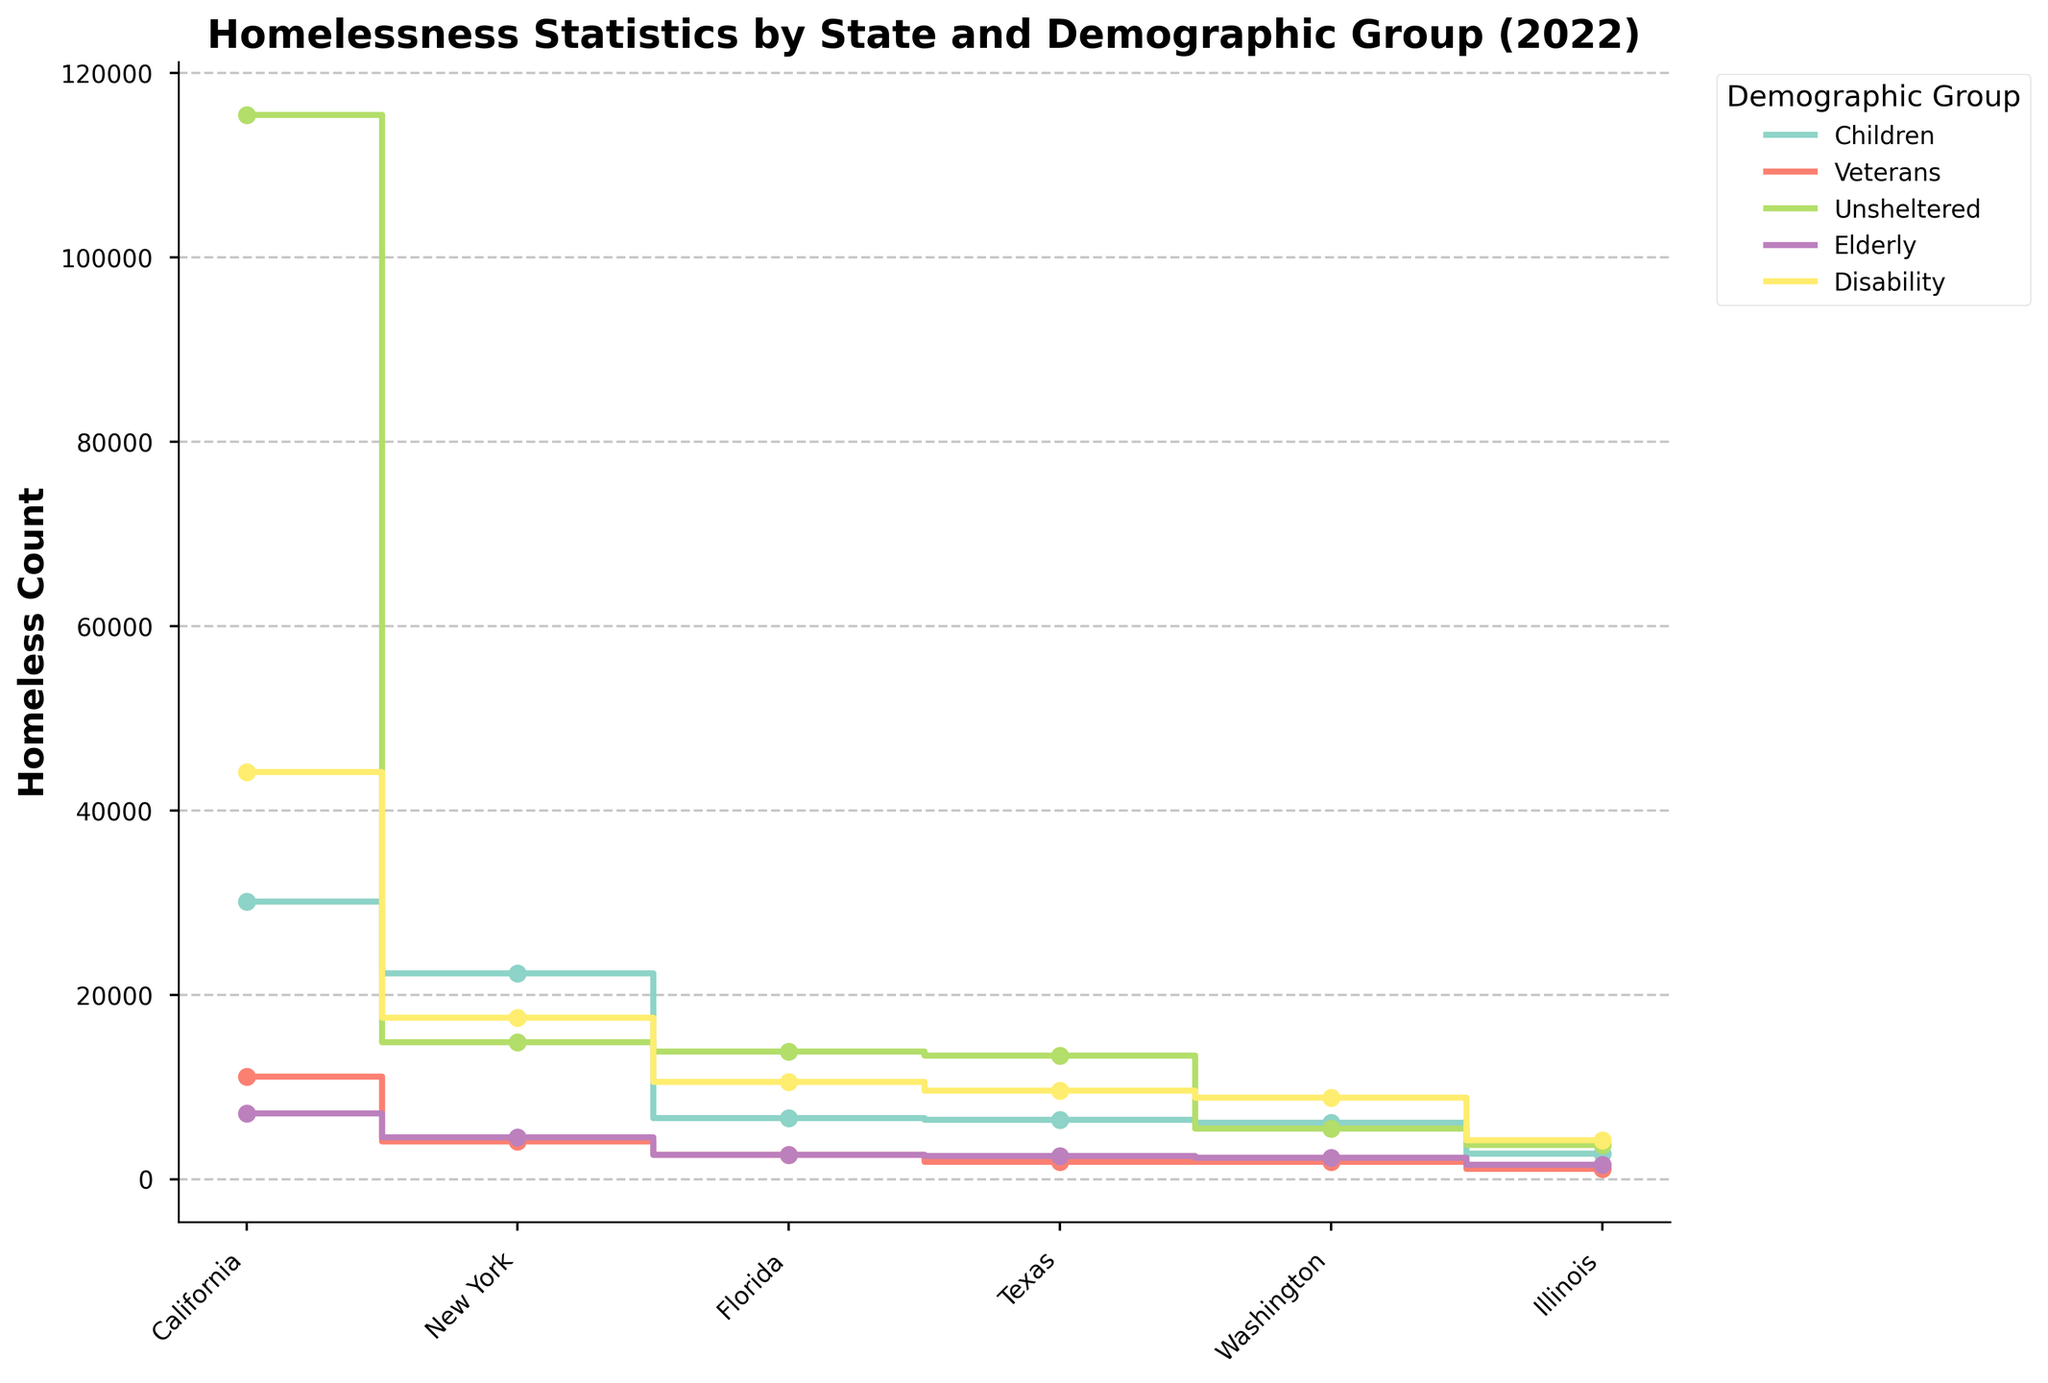Which state has the highest count of unsheltered homeless individuals? In the figure, observe the "Unsheltered" group's stair plot. The highest point corresponds to California.
Answer: California Which demographic group has the second-highest homeless count in New York? In the figure, look at the second highest step for New York's demographic groups. This corresponds to the "Children" demographic.
Answer: Children How does the count of veterans' homelessness in Illinois compare with Texas? Compare the heights of the steps for the "Veterans" group in both Illinois and Texas. Texas has significantly higher veterans' homelessness compared to Illinois.
Answer: Illinois has fewer veterans' homelessness than Texas What's the difference in homeless count between the "Disability" group in Washington and Illinois? Locate the steps for the "Disability" group for Washington and Illinois. Washington's count (10542) is significantly higher than Illinois' count (4190). Calculate the difference: 10542 - 4190 = 6352.
Answer: 6352 In terms of the elderly demographic group, which state has the lowest homelessness count? Observe the steps of the "Elderly" group. The lowest step corresponds to Illinois.
Answer: Illinois Which state has the highest total homeless count, and what is the value? Identify the tallest step in the "Overall" group. The highest total homeless count step corresponds to California, with a value of 161548.
Answer: California, 161548 How does the homeless count of children in Florida differ from that in Washington? Compare the steps for the "Children" demographic group between Florida and Washington. Subtract Washington's count (6412) from Florida's count (6597): 6597 - 6412 = 185.
Answer: 185 In which state does the "Disability" group have the homeless count closest to the "Unsheltered" group? Compare the steps and observe where the "Disability" and "Unsheltered" steps are closest. In Texas, the numbers for both demographics are very close: Disability (8814) and Unsheltered (13405).
Answer: Texas What is the average homeless count for veterans across all states? Sum the veteran counts across all states: 11101 (CA) + 4074 (NY) + 2608 (FL) + 1889 (TX) + 1890 (WA) + 1098 (IL) = 21960. Divide by 6 (number of states): 21960 / 6 = 3660.
Answer: 3660 